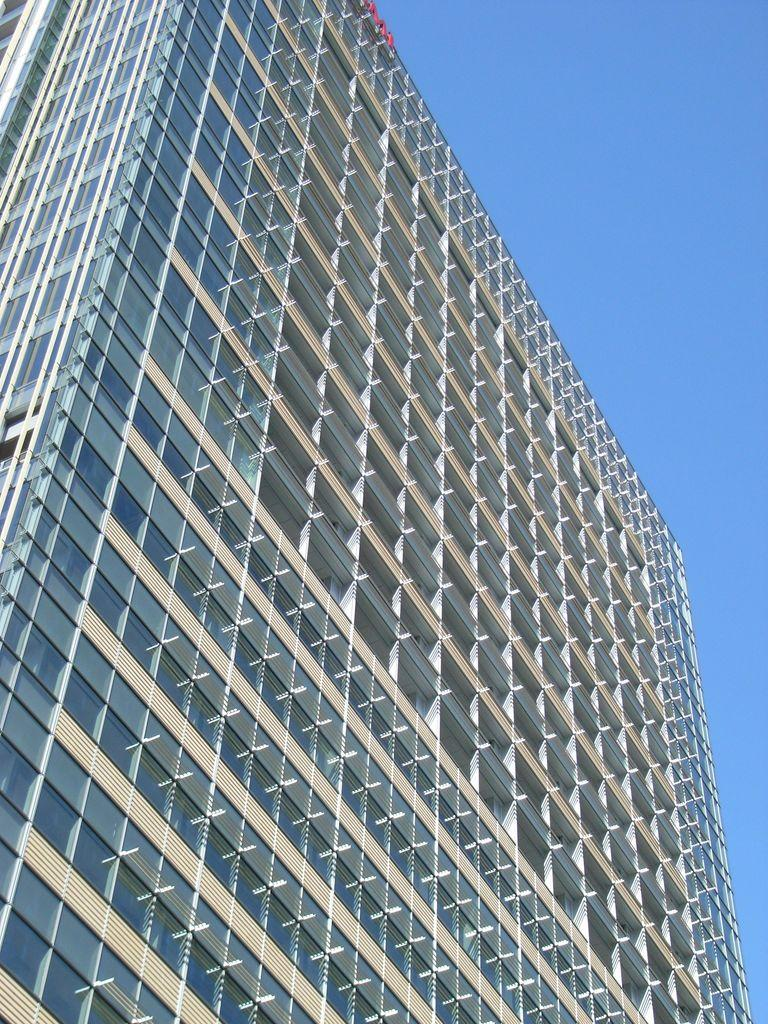What type of structure is present in the image? There is a building in the image. What part of the natural environment is visible in the image? The sky is visible in the image. What type of flooring can be seen in the image? There is no specific flooring visible in the image, as it only shows a building and the sky. What is the starting point for the building in the image? The facts provided do not specify a starting point for the building in the image. 